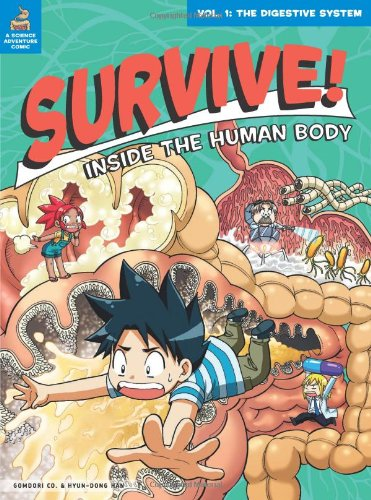What age range is this book appropriate for? This book is most suitable for children aged 7-12, designed to make learning about the human body both fun and informative for elementary and middle school students. 